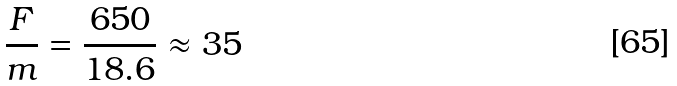Convert formula to latex. <formula><loc_0><loc_0><loc_500><loc_500>\frac { F } { m } = \frac { 6 5 0 } { 1 8 . 6 } \approx 3 5</formula> 